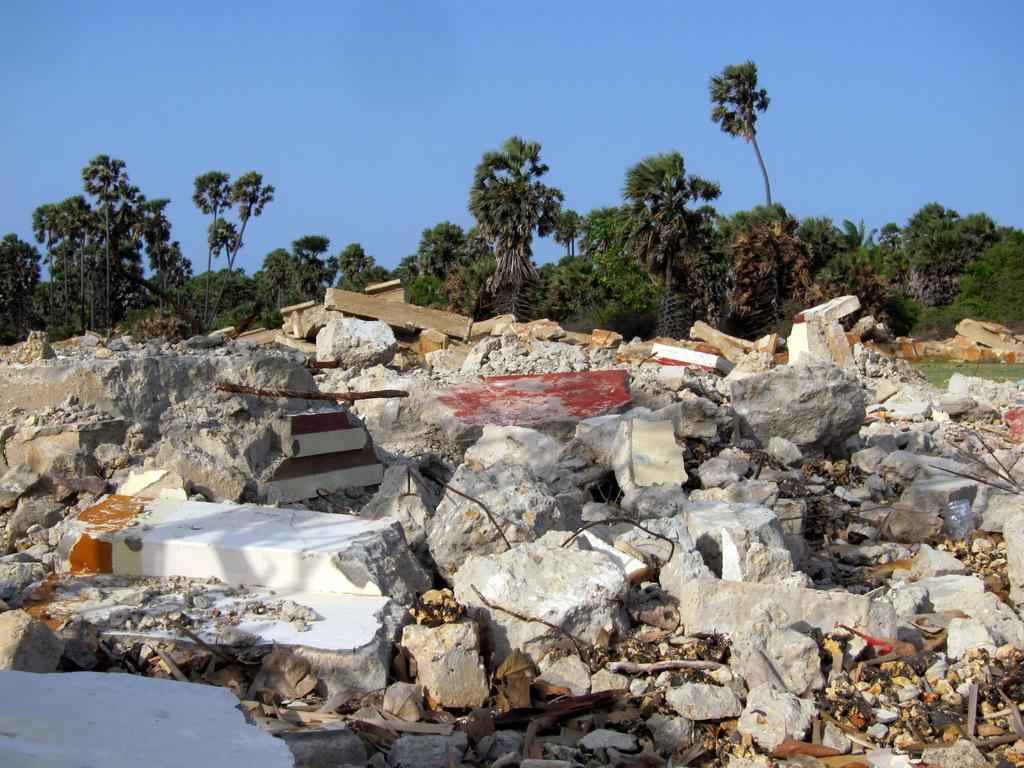What type of natural elements can be seen in the image? There are rocks in the image. What is the color of the sky in the image? The sky is blue in color. What is the reason for the shocking behavior of the balls in the image? There are no balls present in the image, so there is no shocking behavior to analyze. 